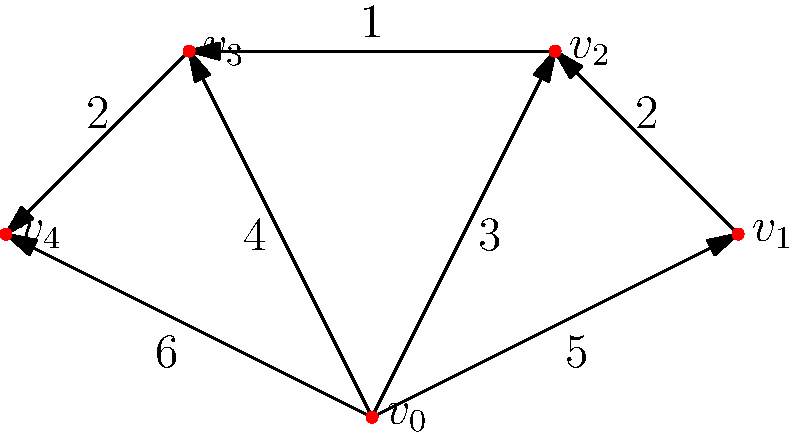As a sports marketing manager, you need to plan a promotional tour for your team's upcoming championship game. The graph represents different venues (vertices) and the travel time between them (edge weights). Starting from venue $v_0$, what is the minimum total travel time required to visit all venues exactly once and return to $v_0$? To solve this problem, we need to find the Hamiltonian cycle with the minimum total weight in the given graph. This is known as the Traveling Salesman Problem (TSP). Since the graph is small, we can solve it by considering all possible paths:

1. List all possible Hamiltonian cycles starting and ending at $v_0$:
   - $v_0 \rightarrow v_1 \rightarrow v_2 \rightarrow v_3 \rightarrow v_4 \rightarrow v_0$
   - $v_0 \rightarrow v_1 \rightarrow v_2 \rightarrow v_4 \rightarrow v_3 \rightarrow v_0$
   - $v_0 \rightarrow v_2 \rightarrow v_1 \rightarrow v_3 \rightarrow v_4 \rightarrow v_0$
   - $v_0 \rightarrow v_2 \rightarrow v_3 \rightarrow v_1 \rightarrow v_4 \rightarrow v_0$
   - $v_0 \rightarrow v_3 \rightarrow v_2 \rightarrow v_1 \rightarrow v_4 \rightarrow v_0$
   - $v_0 \rightarrow v_3 \rightarrow v_4 \rightarrow v_2 \rightarrow v_1 \rightarrow v_0$
   - $v_0 \rightarrow v_4 \rightarrow v_3 \rightarrow v_2 \rightarrow v_1 \rightarrow v_0$

2. Calculate the total weight for each cycle:
   - $5 + 2 + 1 + 2 + 6 = 16$
   - $5 + 2 + 2 + 4 + 6 = 19$
   - $3 + 2 + 4 + 2 + 6 = 17$
   - $3 + 1 + 5 + 2 + 6 = 17$
   - $4 + 1 + 2 + 5 + 6 = 18$
   - $4 + 2 + 3 + 5 + 6 = 20$
   - $6 + 2 + 1 + 2 + 5 = 16$

3. Identify the minimum total weight:
   The minimum total weight is 16, which occurs for two cycles:
   - $v_0 \rightarrow v_1 \rightarrow v_2 \rightarrow v_3 \rightarrow v_4 \rightarrow v_0$
   - $v_0 \rightarrow v_4 \rightarrow v_3 \rightarrow v_2 \rightarrow v_1 \rightarrow v_0$

Therefore, the minimum total travel time required to visit all venues exactly once and return to $v_0$ is 16 units.
Answer: 16 